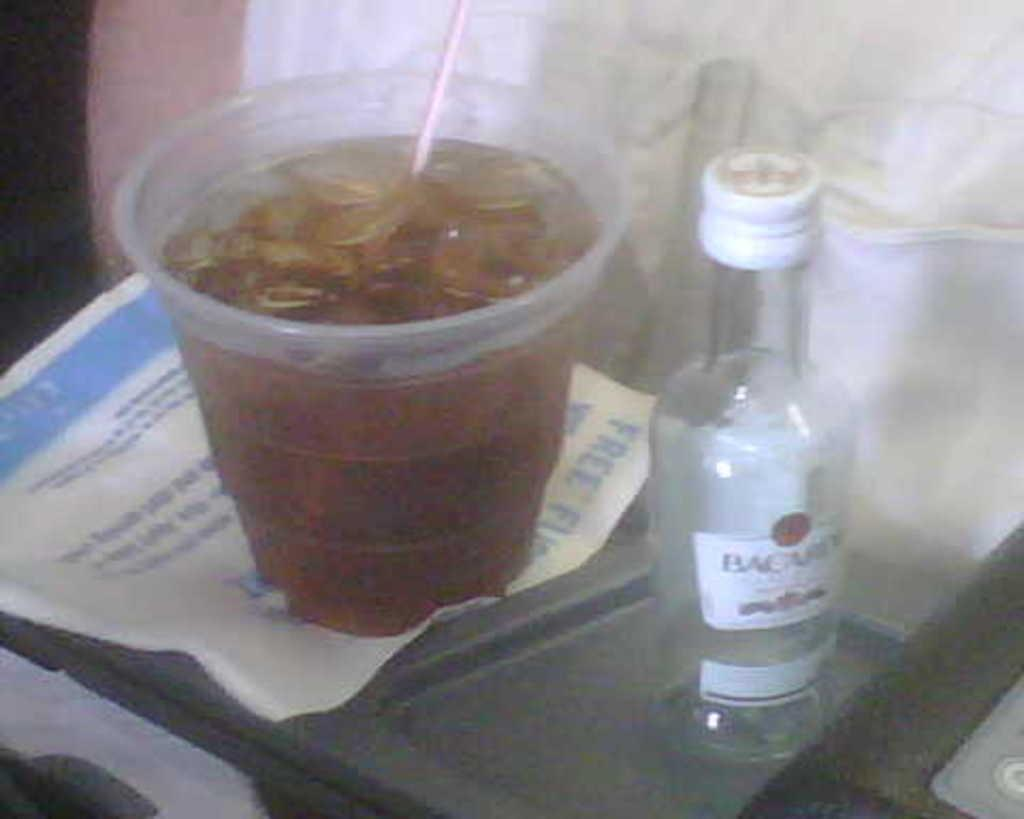<image>
Write a terse but informative summary of the picture. A small bottle with a white cap that is labelled "Bacardi". 